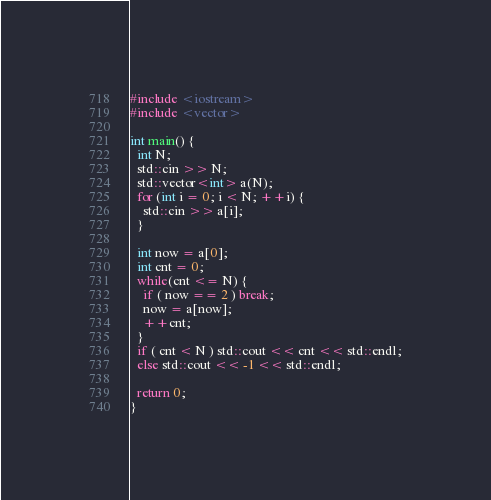<code> <loc_0><loc_0><loc_500><loc_500><_C++_>#include <iostream>
#include <vector>

int main() {
  int N;
  std::cin >> N;
  std::vector<int> a(N);
  for (int i = 0; i < N; ++i) {
    std::cin >> a[i];
  }

  int now = a[0];
  int cnt = 0;
  while(cnt <= N) {
    if ( now == 2 ) break;
    now = a[now];
    ++cnt;
  }
  if ( cnt < N ) std::cout << cnt << std::endl;
  else std::cout << -1 << std::endl;

  return 0;
}
</code> 